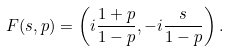<formula> <loc_0><loc_0><loc_500><loc_500>F ( s , p ) = \left ( i \frac { 1 + p } { 1 - p } , - i \frac { s } { 1 - p } \right ) .</formula> 